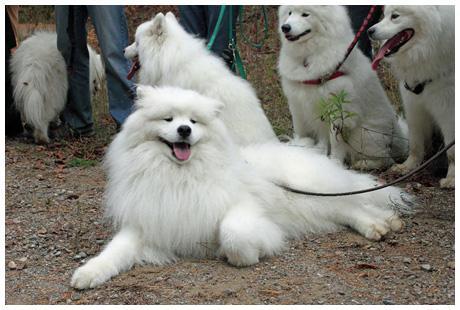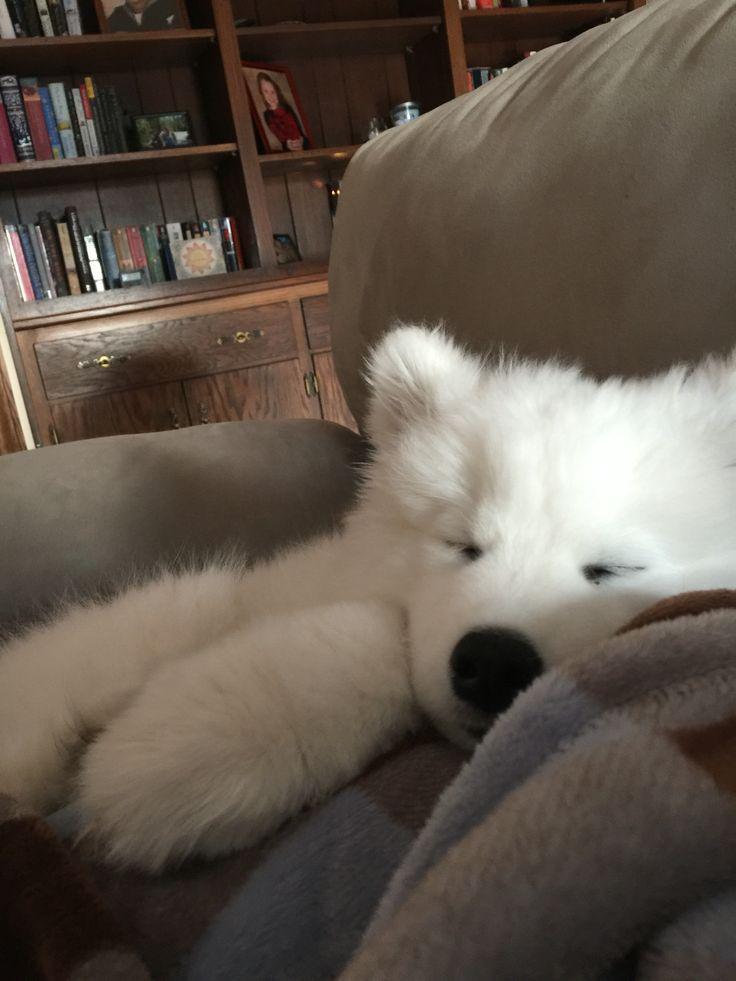The first image is the image on the left, the second image is the image on the right. Examine the images to the left and right. Is the description "At least one dog is laying on a couch." accurate? Answer yes or no. Yes. 